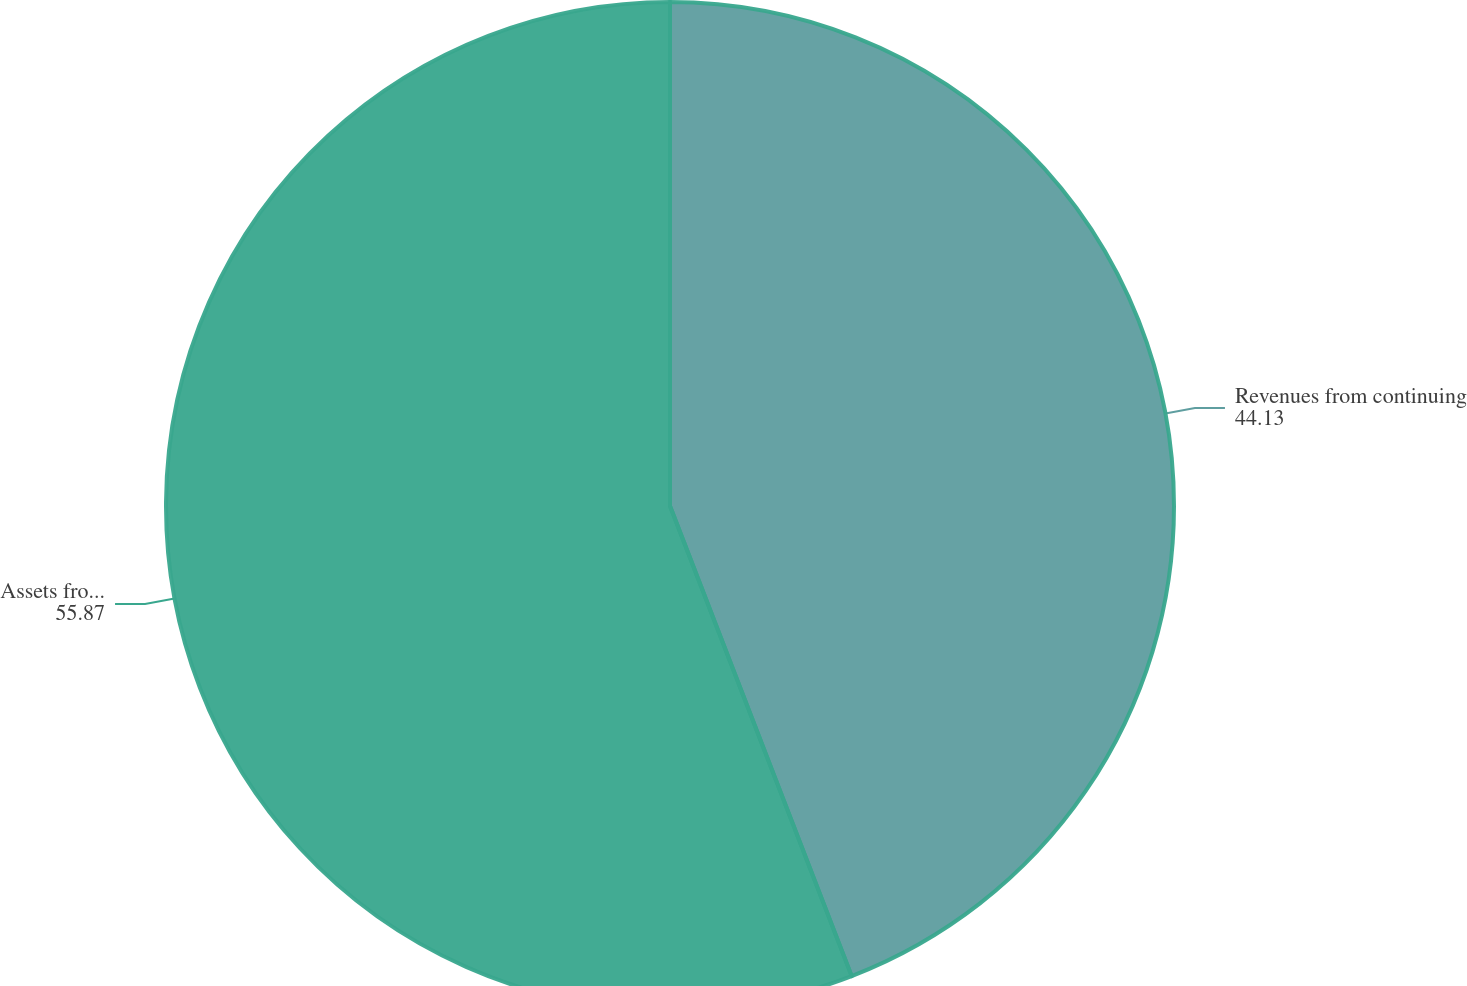Convert chart. <chart><loc_0><loc_0><loc_500><loc_500><pie_chart><fcel>Revenues from continuing<fcel>Assets from continuing<nl><fcel>44.13%<fcel>55.87%<nl></chart> 